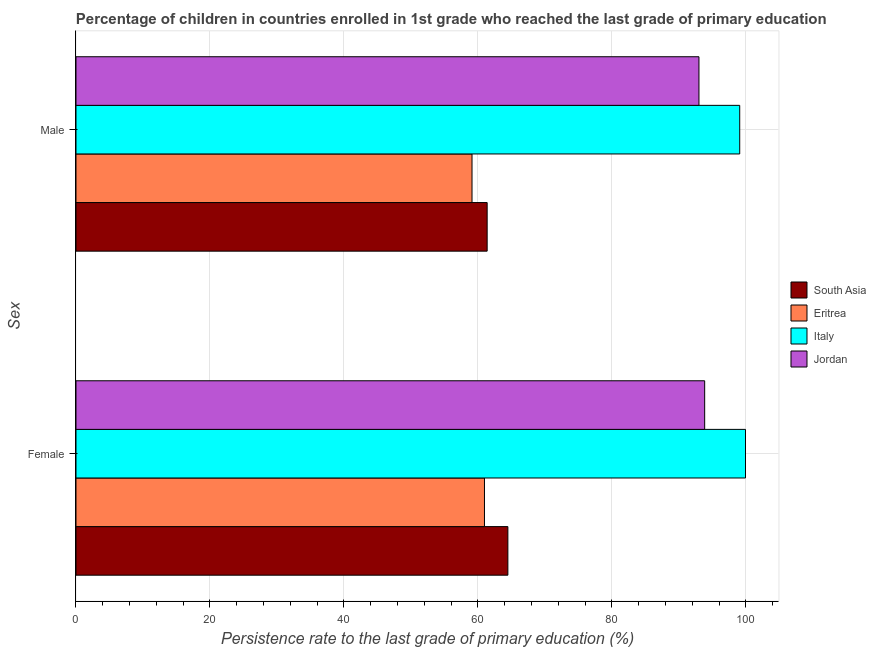How many different coloured bars are there?
Make the answer very short. 4. Are the number of bars per tick equal to the number of legend labels?
Ensure brevity in your answer.  Yes. Are the number of bars on each tick of the Y-axis equal?
Provide a succinct answer. Yes. How many bars are there on the 2nd tick from the bottom?
Offer a terse response. 4. What is the label of the 1st group of bars from the top?
Make the answer very short. Male. What is the persistence rate of female students in Jordan?
Your answer should be compact. 93.85. Across all countries, what is the maximum persistence rate of male students?
Make the answer very short. 99.08. Across all countries, what is the minimum persistence rate of male students?
Ensure brevity in your answer.  59.12. In which country was the persistence rate of male students maximum?
Provide a short and direct response. Italy. In which country was the persistence rate of male students minimum?
Your answer should be compact. Eritrea. What is the total persistence rate of female students in the graph?
Give a very brief answer. 319.24. What is the difference between the persistence rate of male students in Italy and that in South Asia?
Your answer should be very brief. 37.7. What is the difference between the persistence rate of female students in Italy and the persistence rate of male students in Jordan?
Offer a very short reply. 6.95. What is the average persistence rate of female students per country?
Your answer should be very brief. 79.81. What is the difference between the persistence rate of male students and persistence rate of female students in South Asia?
Your answer should be compact. -3.09. In how many countries, is the persistence rate of male students greater than 84 %?
Your response must be concise. 2. What is the ratio of the persistence rate of male students in Jordan to that in South Asia?
Make the answer very short. 1.52. What does the 4th bar from the top in Female represents?
Offer a terse response. South Asia. Are all the bars in the graph horizontal?
Keep it short and to the point. Yes. How many countries are there in the graph?
Offer a very short reply. 4. Does the graph contain any zero values?
Offer a terse response. No. Does the graph contain grids?
Give a very brief answer. Yes. How are the legend labels stacked?
Provide a succinct answer. Vertical. What is the title of the graph?
Offer a very short reply. Percentage of children in countries enrolled in 1st grade who reached the last grade of primary education. What is the label or title of the X-axis?
Keep it short and to the point. Persistence rate to the last grade of primary education (%). What is the label or title of the Y-axis?
Ensure brevity in your answer.  Sex. What is the Persistence rate to the last grade of primary education (%) of South Asia in Female?
Your answer should be compact. 64.47. What is the Persistence rate to the last grade of primary education (%) of Eritrea in Female?
Make the answer very short. 60.98. What is the Persistence rate to the last grade of primary education (%) in Italy in Female?
Your answer should be compact. 99.95. What is the Persistence rate to the last grade of primary education (%) of Jordan in Female?
Make the answer very short. 93.85. What is the Persistence rate to the last grade of primary education (%) of South Asia in Male?
Ensure brevity in your answer.  61.38. What is the Persistence rate to the last grade of primary education (%) of Eritrea in Male?
Your response must be concise. 59.12. What is the Persistence rate to the last grade of primary education (%) in Italy in Male?
Keep it short and to the point. 99.08. What is the Persistence rate to the last grade of primary education (%) in Jordan in Male?
Offer a very short reply. 93. Across all Sex, what is the maximum Persistence rate to the last grade of primary education (%) in South Asia?
Offer a terse response. 64.47. Across all Sex, what is the maximum Persistence rate to the last grade of primary education (%) in Eritrea?
Provide a succinct answer. 60.98. Across all Sex, what is the maximum Persistence rate to the last grade of primary education (%) in Italy?
Provide a short and direct response. 99.95. Across all Sex, what is the maximum Persistence rate to the last grade of primary education (%) of Jordan?
Your answer should be compact. 93.85. Across all Sex, what is the minimum Persistence rate to the last grade of primary education (%) of South Asia?
Keep it short and to the point. 61.38. Across all Sex, what is the minimum Persistence rate to the last grade of primary education (%) in Eritrea?
Provide a succinct answer. 59.12. Across all Sex, what is the minimum Persistence rate to the last grade of primary education (%) of Italy?
Your response must be concise. 99.08. Across all Sex, what is the minimum Persistence rate to the last grade of primary education (%) in Jordan?
Give a very brief answer. 93. What is the total Persistence rate to the last grade of primary education (%) of South Asia in the graph?
Ensure brevity in your answer.  125.85. What is the total Persistence rate to the last grade of primary education (%) in Eritrea in the graph?
Provide a succinct answer. 120.1. What is the total Persistence rate to the last grade of primary education (%) in Italy in the graph?
Your answer should be very brief. 199.03. What is the total Persistence rate to the last grade of primary education (%) in Jordan in the graph?
Keep it short and to the point. 186.85. What is the difference between the Persistence rate to the last grade of primary education (%) in South Asia in Female and that in Male?
Keep it short and to the point. 3.09. What is the difference between the Persistence rate to the last grade of primary education (%) of Eritrea in Female and that in Male?
Provide a short and direct response. 1.86. What is the difference between the Persistence rate to the last grade of primary education (%) in Italy in Female and that in Male?
Give a very brief answer. 0.86. What is the difference between the Persistence rate to the last grade of primary education (%) of Jordan in Female and that in Male?
Provide a short and direct response. 0.85. What is the difference between the Persistence rate to the last grade of primary education (%) in South Asia in Female and the Persistence rate to the last grade of primary education (%) in Eritrea in Male?
Give a very brief answer. 5.35. What is the difference between the Persistence rate to the last grade of primary education (%) in South Asia in Female and the Persistence rate to the last grade of primary education (%) in Italy in Male?
Your answer should be very brief. -34.61. What is the difference between the Persistence rate to the last grade of primary education (%) of South Asia in Female and the Persistence rate to the last grade of primary education (%) of Jordan in Male?
Provide a succinct answer. -28.52. What is the difference between the Persistence rate to the last grade of primary education (%) of Eritrea in Female and the Persistence rate to the last grade of primary education (%) of Italy in Male?
Provide a succinct answer. -38.1. What is the difference between the Persistence rate to the last grade of primary education (%) of Eritrea in Female and the Persistence rate to the last grade of primary education (%) of Jordan in Male?
Make the answer very short. -32.02. What is the difference between the Persistence rate to the last grade of primary education (%) of Italy in Female and the Persistence rate to the last grade of primary education (%) of Jordan in Male?
Keep it short and to the point. 6.95. What is the average Persistence rate to the last grade of primary education (%) in South Asia per Sex?
Provide a succinct answer. 62.93. What is the average Persistence rate to the last grade of primary education (%) of Eritrea per Sex?
Make the answer very short. 60.05. What is the average Persistence rate to the last grade of primary education (%) of Italy per Sex?
Give a very brief answer. 99.51. What is the average Persistence rate to the last grade of primary education (%) of Jordan per Sex?
Make the answer very short. 93.42. What is the difference between the Persistence rate to the last grade of primary education (%) of South Asia and Persistence rate to the last grade of primary education (%) of Eritrea in Female?
Your response must be concise. 3.5. What is the difference between the Persistence rate to the last grade of primary education (%) of South Asia and Persistence rate to the last grade of primary education (%) of Italy in Female?
Your response must be concise. -35.47. What is the difference between the Persistence rate to the last grade of primary education (%) of South Asia and Persistence rate to the last grade of primary education (%) of Jordan in Female?
Your answer should be very brief. -29.38. What is the difference between the Persistence rate to the last grade of primary education (%) in Eritrea and Persistence rate to the last grade of primary education (%) in Italy in Female?
Offer a terse response. -38.97. What is the difference between the Persistence rate to the last grade of primary education (%) in Eritrea and Persistence rate to the last grade of primary education (%) in Jordan in Female?
Your answer should be very brief. -32.87. What is the difference between the Persistence rate to the last grade of primary education (%) in Italy and Persistence rate to the last grade of primary education (%) in Jordan in Female?
Your answer should be very brief. 6.1. What is the difference between the Persistence rate to the last grade of primary education (%) in South Asia and Persistence rate to the last grade of primary education (%) in Eritrea in Male?
Make the answer very short. 2.26. What is the difference between the Persistence rate to the last grade of primary education (%) of South Asia and Persistence rate to the last grade of primary education (%) of Italy in Male?
Your answer should be compact. -37.7. What is the difference between the Persistence rate to the last grade of primary education (%) in South Asia and Persistence rate to the last grade of primary education (%) in Jordan in Male?
Your answer should be compact. -31.62. What is the difference between the Persistence rate to the last grade of primary education (%) of Eritrea and Persistence rate to the last grade of primary education (%) of Italy in Male?
Offer a terse response. -39.96. What is the difference between the Persistence rate to the last grade of primary education (%) of Eritrea and Persistence rate to the last grade of primary education (%) of Jordan in Male?
Your response must be concise. -33.88. What is the difference between the Persistence rate to the last grade of primary education (%) of Italy and Persistence rate to the last grade of primary education (%) of Jordan in Male?
Your response must be concise. 6.09. What is the ratio of the Persistence rate to the last grade of primary education (%) of South Asia in Female to that in Male?
Keep it short and to the point. 1.05. What is the ratio of the Persistence rate to the last grade of primary education (%) of Eritrea in Female to that in Male?
Provide a succinct answer. 1.03. What is the ratio of the Persistence rate to the last grade of primary education (%) in Italy in Female to that in Male?
Offer a very short reply. 1.01. What is the ratio of the Persistence rate to the last grade of primary education (%) of Jordan in Female to that in Male?
Your answer should be very brief. 1.01. What is the difference between the highest and the second highest Persistence rate to the last grade of primary education (%) in South Asia?
Your response must be concise. 3.09. What is the difference between the highest and the second highest Persistence rate to the last grade of primary education (%) of Eritrea?
Make the answer very short. 1.86. What is the difference between the highest and the second highest Persistence rate to the last grade of primary education (%) of Italy?
Make the answer very short. 0.86. What is the difference between the highest and the second highest Persistence rate to the last grade of primary education (%) of Jordan?
Provide a succinct answer. 0.85. What is the difference between the highest and the lowest Persistence rate to the last grade of primary education (%) of South Asia?
Keep it short and to the point. 3.09. What is the difference between the highest and the lowest Persistence rate to the last grade of primary education (%) in Eritrea?
Offer a terse response. 1.86. What is the difference between the highest and the lowest Persistence rate to the last grade of primary education (%) of Italy?
Ensure brevity in your answer.  0.86. What is the difference between the highest and the lowest Persistence rate to the last grade of primary education (%) of Jordan?
Keep it short and to the point. 0.85. 